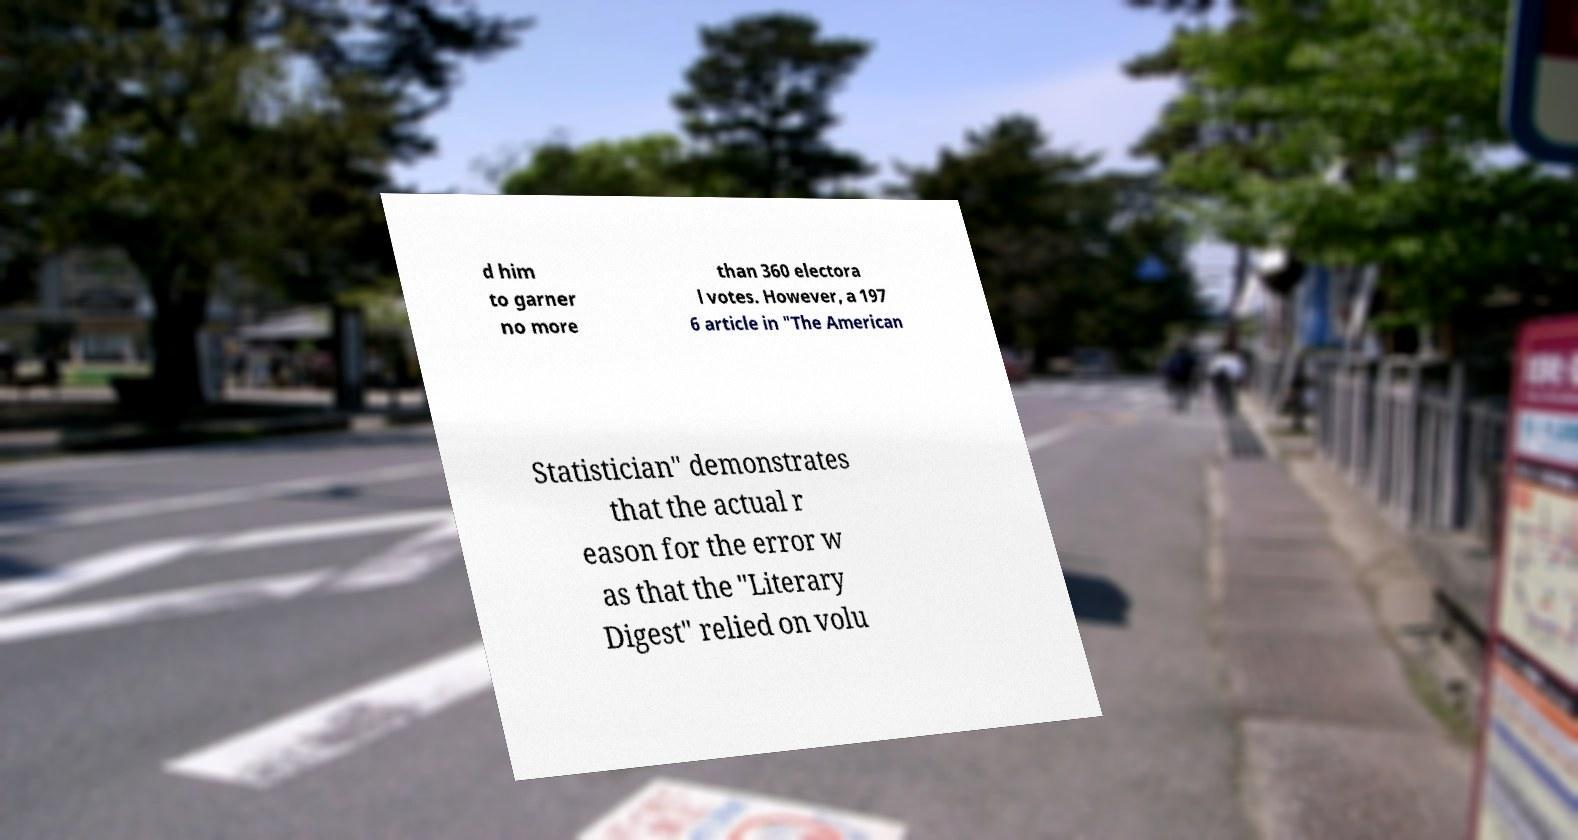Please read and relay the text visible in this image. What does it say? d him to garner no more than 360 electora l votes. However, a 197 6 article in "The American Statistician" demonstrates that the actual r eason for the error w as that the "Literary Digest" relied on volu 